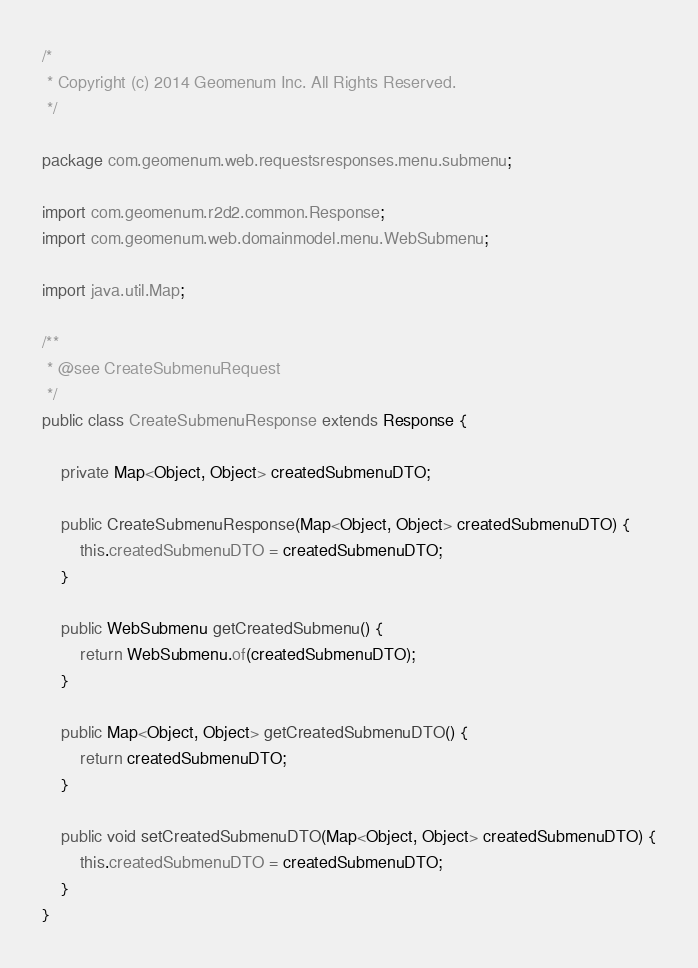<code> <loc_0><loc_0><loc_500><loc_500><_Java_>/*
 * Copyright (c) 2014 Geomenum Inc. All Rights Reserved.
 */

package com.geomenum.web.requestsresponses.menu.submenu;

import com.geomenum.r2d2.common.Response;
import com.geomenum.web.domainmodel.menu.WebSubmenu;

import java.util.Map;

/**
 * @see CreateSubmenuRequest
 */
public class CreateSubmenuResponse extends Response {

    private Map<Object, Object> createdSubmenuDTO;

    public CreateSubmenuResponse(Map<Object, Object> createdSubmenuDTO) {
        this.createdSubmenuDTO = createdSubmenuDTO;
    }

    public WebSubmenu getCreatedSubmenu() {
        return WebSubmenu.of(createdSubmenuDTO);
    }

    public Map<Object, Object> getCreatedSubmenuDTO() {
        return createdSubmenuDTO;
    }

    public void setCreatedSubmenuDTO(Map<Object, Object> createdSubmenuDTO) {
        this.createdSubmenuDTO = createdSubmenuDTO;
    }
}
</code> 